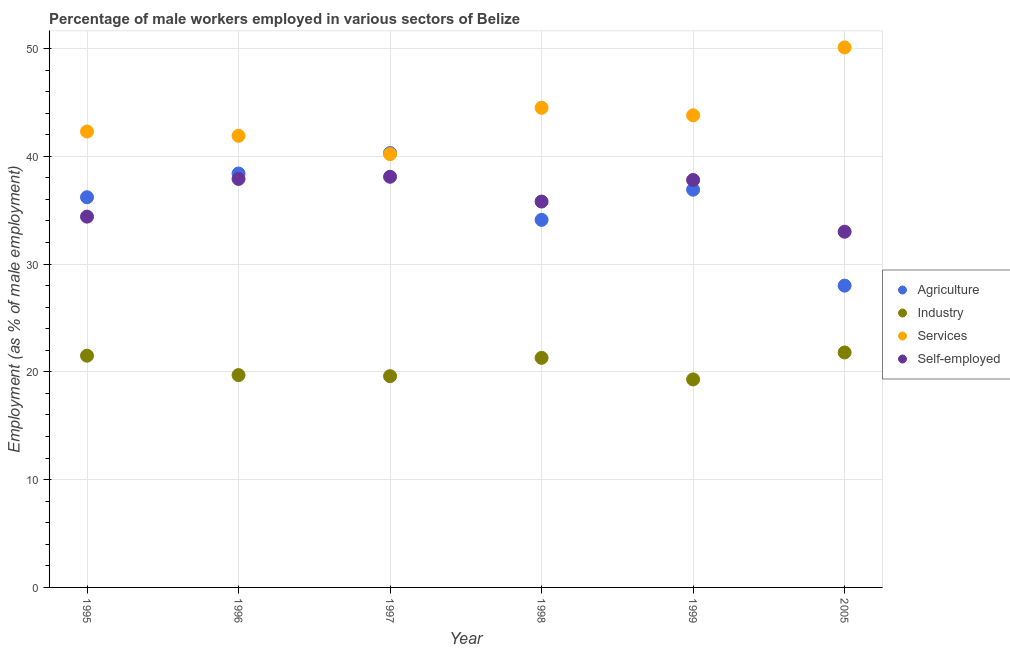Is the number of dotlines equal to the number of legend labels?
Provide a short and direct response. Yes. What is the percentage of self employed male workers in 1995?
Make the answer very short. 34.4. Across all years, what is the maximum percentage of self employed male workers?
Ensure brevity in your answer.  38.1. Across all years, what is the minimum percentage of male workers in agriculture?
Keep it short and to the point. 28. In which year was the percentage of male workers in industry maximum?
Keep it short and to the point. 2005. In which year was the percentage of male workers in agriculture minimum?
Offer a terse response. 2005. What is the total percentage of self employed male workers in the graph?
Your response must be concise. 217. What is the difference between the percentage of male workers in agriculture in 1996 and that in 1997?
Provide a short and direct response. -1.9. What is the difference between the percentage of self employed male workers in 1997 and the percentage of male workers in industry in 1995?
Make the answer very short. 16.6. What is the average percentage of male workers in agriculture per year?
Keep it short and to the point. 35.65. In the year 1995, what is the difference between the percentage of male workers in services and percentage of self employed male workers?
Provide a succinct answer. 7.9. What is the ratio of the percentage of male workers in industry in 1998 to that in 1999?
Give a very brief answer. 1.1. What is the difference between the highest and the second highest percentage of self employed male workers?
Provide a succinct answer. 0.2. What is the difference between the highest and the lowest percentage of male workers in services?
Your answer should be very brief. 9.9. Is the sum of the percentage of male workers in industry in 1996 and 1998 greater than the maximum percentage of self employed male workers across all years?
Make the answer very short. Yes. Is it the case that in every year, the sum of the percentage of male workers in industry and percentage of male workers in services is greater than the sum of percentage of self employed male workers and percentage of male workers in agriculture?
Your answer should be compact. No. How many dotlines are there?
Provide a short and direct response. 4. What is the difference between two consecutive major ticks on the Y-axis?
Your response must be concise. 10. Does the graph contain any zero values?
Ensure brevity in your answer.  No. Does the graph contain grids?
Ensure brevity in your answer.  Yes. Where does the legend appear in the graph?
Keep it short and to the point. Center right. How are the legend labels stacked?
Keep it short and to the point. Vertical. What is the title of the graph?
Offer a terse response. Percentage of male workers employed in various sectors of Belize. What is the label or title of the X-axis?
Ensure brevity in your answer.  Year. What is the label or title of the Y-axis?
Your response must be concise. Employment (as % of male employment). What is the Employment (as % of male employment) of Agriculture in 1995?
Offer a very short reply. 36.2. What is the Employment (as % of male employment) in Services in 1995?
Keep it short and to the point. 42.3. What is the Employment (as % of male employment) in Self-employed in 1995?
Offer a very short reply. 34.4. What is the Employment (as % of male employment) in Agriculture in 1996?
Your response must be concise. 38.4. What is the Employment (as % of male employment) of Industry in 1996?
Make the answer very short. 19.7. What is the Employment (as % of male employment) of Services in 1996?
Your answer should be compact. 41.9. What is the Employment (as % of male employment) in Self-employed in 1996?
Offer a terse response. 37.9. What is the Employment (as % of male employment) of Agriculture in 1997?
Offer a very short reply. 40.3. What is the Employment (as % of male employment) of Industry in 1997?
Ensure brevity in your answer.  19.6. What is the Employment (as % of male employment) of Services in 1997?
Your response must be concise. 40.2. What is the Employment (as % of male employment) in Self-employed in 1997?
Give a very brief answer. 38.1. What is the Employment (as % of male employment) in Agriculture in 1998?
Make the answer very short. 34.1. What is the Employment (as % of male employment) in Industry in 1998?
Your response must be concise. 21.3. What is the Employment (as % of male employment) in Services in 1998?
Ensure brevity in your answer.  44.5. What is the Employment (as % of male employment) of Self-employed in 1998?
Offer a very short reply. 35.8. What is the Employment (as % of male employment) in Agriculture in 1999?
Offer a very short reply. 36.9. What is the Employment (as % of male employment) in Industry in 1999?
Your answer should be very brief. 19.3. What is the Employment (as % of male employment) of Services in 1999?
Make the answer very short. 43.8. What is the Employment (as % of male employment) of Self-employed in 1999?
Provide a succinct answer. 37.8. What is the Employment (as % of male employment) in Agriculture in 2005?
Offer a very short reply. 28. What is the Employment (as % of male employment) in Industry in 2005?
Your response must be concise. 21.8. What is the Employment (as % of male employment) in Services in 2005?
Your response must be concise. 50.1. Across all years, what is the maximum Employment (as % of male employment) in Agriculture?
Keep it short and to the point. 40.3. Across all years, what is the maximum Employment (as % of male employment) of Industry?
Your answer should be compact. 21.8. Across all years, what is the maximum Employment (as % of male employment) in Services?
Your answer should be compact. 50.1. Across all years, what is the maximum Employment (as % of male employment) in Self-employed?
Keep it short and to the point. 38.1. Across all years, what is the minimum Employment (as % of male employment) of Agriculture?
Your answer should be compact. 28. Across all years, what is the minimum Employment (as % of male employment) of Industry?
Give a very brief answer. 19.3. Across all years, what is the minimum Employment (as % of male employment) of Services?
Keep it short and to the point. 40.2. What is the total Employment (as % of male employment) of Agriculture in the graph?
Offer a very short reply. 213.9. What is the total Employment (as % of male employment) of Industry in the graph?
Make the answer very short. 123.2. What is the total Employment (as % of male employment) in Services in the graph?
Your response must be concise. 262.8. What is the total Employment (as % of male employment) of Self-employed in the graph?
Offer a terse response. 217. What is the difference between the Employment (as % of male employment) in Agriculture in 1995 and that in 1996?
Offer a very short reply. -2.2. What is the difference between the Employment (as % of male employment) in Industry in 1995 and that in 1996?
Your answer should be very brief. 1.8. What is the difference between the Employment (as % of male employment) in Services in 1995 and that in 1997?
Provide a succinct answer. 2.1. What is the difference between the Employment (as % of male employment) of Self-employed in 1995 and that in 1997?
Offer a terse response. -3.7. What is the difference between the Employment (as % of male employment) of Agriculture in 1995 and that in 1998?
Your response must be concise. 2.1. What is the difference between the Employment (as % of male employment) of Agriculture in 1995 and that in 1999?
Offer a terse response. -0.7. What is the difference between the Employment (as % of male employment) of Industry in 1995 and that in 1999?
Give a very brief answer. 2.2. What is the difference between the Employment (as % of male employment) of Agriculture in 1995 and that in 2005?
Your response must be concise. 8.2. What is the difference between the Employment (as % of male employment) in Industry in 1995 and that in 2005?
Keep it short and to the point. -0.3. What is the difference between the Employment (as % of male employment) of Agriculture in 1996 and that in 1997?
Make the answer very short. -1.9. What is the difference between the Employment (as % of male employment) of Agriculture in 1996 and that in 1998?
Keep it short and to the point. 4.3. What is the difference between the Employment (as % of male employment) in Industry in 1996 and that in 1998?
Make the answer very short. -1.6. What is the difference between the Employment (as % of male employment) in Services in 1996 and that in 1998?
Provide a short and direct response. -2.6. What is the difference between the Employment (as % of male employment) in Self-employed in 1996 and that in 1998?
Your answer should be compact. 2.1. What is the difference between the Employment (as % of male employment) in Services in 1996 and that in 1999?
Your answer should be very brief. -1.9. What is the difference between the Employment (as % of male employment) of Services in 1996 and that in 2005?
Keep it short and to the point. -8.2. What is the difference between the Employment (as % of male employment) in Self-employed in 1996 and that in 2005?
Your answer should be compact. 4.9. What is the difference between the Employment (as % of male employment) in Agriculture in 1997 and that in 1998?
Your answer should be compact. 6.2. What is the difference between the Employment (as % of male employment) in Industry in 1997 and that in 1998?
Make the answer very short. -1.7. What is the difference between the Employment (as % of male employment) in Services in 1997 and that in 1998?
Make the answer very short. -4.3. What is the difference between the Employment (as % of male employment) in Self-employed in 1997 and that in 1998?
Give a very brief answer. 2.3. What is the difference between the Employment (as % of male employment) of Industry in 1997 and that in 1999?
Offer a terse response. 0.3. What is the difference between the Employment (as % of male employment) of Services in 1997 and that in 1999?
Give a very brief answer. -3.6. What is the difference between the Employment (as % of male employment) of Self-employed in 1997 and that in 2005?
Provide a succinct answer. 5.1. What is the difference between the Employment (as % of male employment) in Agriculture in 1998 and that in 1999?
Offer a very short reply. -2.8. What is the difference between the Employment (as % of male employment) of Industry in 1998 and that in 1999?
Offer a very short reply. 2. What is the difference between the Employment (as % of male employment) of Services in 1998 and that in 1999?
Provide a short and direct response. 0.7. What is the difference between the Employment (as % of male employment) of Agriculture in 1999 and that in 2005?
Provide a short and direct response. 8.9. What is the difference between the Employment (as % of male employment) of Industry in 1999 and that in 2005?
Provide a short and direct response. -2.5. What is the difference between the Employment (as % of male employment) of Services in 1999 and that in 2005?
Give a very brief answer. -6.3. What is the difference between the Employment (as % of male employment) in Agriculture in 1995 and the Employment (as % of male employment) in Self-employed in 1996?
Your answer should be compact. -1.7. What is the difference between the Employment (as % of male employment) in Industry in 1995 and the Employment (as % of male employment) in Services in 1996?
Give a very brief answer. -20.4. What is the difference between the Employment (as % of male employment) in Industry in 1995 and the Employment (as % of male employment) in Self-employed in 1996?
Offer a terse response. -16.4. What is the difference between the Employment (as % of male employment) of Agriculture in 1995 and the Employment (as % of male employment) of Services in 1997?
Your answer should be compact. -4. What is the difference between the Employment (as % of male employment) in Industry in 1995 and the Employment (as % of male employment) in Services in 1997?
Ensure brevity in your answer.  -18.7. What is the difference between the Employment (as % of male employment) of Industry in 1995 and the Employment (as % of male employment) of Self-employed in 1997?
Offer a very short reply. -16.6. What is the difference between the Employment (as % of male employment) in Industry in 1995 and the Employment (as % of male employment) in Services in 1998?
Your answer should be compact. -23. What is the difference between the Employment (as % of male employment) of Industry in 1995 and the Employment (as % of male employment) of Self-employed in 1998?
Your response must be concise. -14.3. What is the difference between the Employment (as % of male employment) of Services in 1995 and the Employment (as % of male employment) of Self-employed in 1998?
Make the answer very short. 6.5. What is the difference between the Employment (as % of male employment) of Agriculture in 1995 and the Employment (as % of male employment) of Industry in 1999?
Ensure brevity in your answer.  16.9. What is the difference between the Employment (as % of male employment) of Industry in 1995 and the Employment (as % of male employment) of Services in 1999?
Offer a terse response. -22.3. What is the difference between the Employment (as % of male employment) of Industry in 1995 and the Employment (as % of male employment) of Self-employed in 1999?
Provide a short and direct response. -16.3. What is the difference between the Employment (as % of male employment) in Agriculture in 1995 and the Employment (as % of male employment) in Industry in 2005?
Your response must be concise. 14.4. What is the difference between the Employment (as % of male employment) in Industry in 1995 and the Employment (as % of male employment) in Services in 2005?
Make the answer very short. -28.6. What is the difference between the Employment (as % of male employment) in Services in 1995 and the Employment (as % of male employment) in Self-employed in 2005?
Offer a very short reply. 9.3. What is the difference between the Employment (as % of male employment) in Agriculture in 1996 and the Employment (as % of male employment) in Services in 1997?
Your answer should be very brief. -1.8. What is the difference between the Employment (as % of male employment) in Industry in 1996 and the Employment (as % of male employment) in Services in 1997?
Your answer should be compact. -20.5. What is the difference between the Employment (as % of male employment) in Industry in 1996 and the Employment (as % of male employment) in Self-employed in 1997?
Your answer should be very brief. -18.4. What is the difference between the Employment (as % of male employment) in Services in 1996 and the Employment (as % of male employment) in Self-employed in 1997?
Offer a very short reply. 3.8. What is the difference between the Employment (as % of male employment) of Industry in 1996 and the Employment (as % of male employment) of Services in 1998?
Keep it short and to the point. -24.8. What is the difference between the Employment (as % of male employment) in Industry in 1996 and the Employment (as % of male employment) in Self-employed in 1998?
Make the answer very short. -16.1. What is the difference between the Employment (as % of male employment) of Agriculture in 1996 and the Employment (as % of male employment) of Industry in 1999?
Provide a short and direct response. 19.1. What is the difference between the Employment (as % of male employment) of Agriculture in 1996 and the Employment (as % of male employment) of Self-employed in 1999?
Your answer should be very brief. 0.6. What is the difference between the Employment (as % of male employment) in Industry in 1996 and the Employment (as % of male employment) in Services in 1999?
Offer a very short reply. -24.1. What is the difference between the Employment (as % of male employment) of Industry in 1996 and the Employment (as % of male employment) of Self-employed in 1999?
Make the answer very short. -18.1. What is the difference between the Employment (as % of male employment) in Agriculture in 1996 and the Employment (as % of male employment) in Industry in 2005?
Your answer should be very brief. 16.6. What is the difference between the Employment (as % of male employment) of Industry in 1996 and the Employment (as % of male employment) of Services in 2005?
Your answer should be compact. -30.4. What is the difference between the Employment (as % of male employment) in Services in 1996 and the Employment (as % of male employment) in Self-employed in 2005?
Provide a short and direct response. 8.9. What is the difference between the Employment (as % of male employment) of Agriculture in 1997 and the Employment (as % of male employment) of Industry in 1998?
Your answer should be very brief. 19. What is the difference between the Employment (as % of male employment) in Agriculture in 1997 and the Employment (as % of male employment) in Services in 1998?
Your answer should be compact. -4.2. What is the difference between the Employment (as % of male employment) of Agriculture in 1997 and the Employment (as % of male employment) of Self-employed in 1998?
Your answer should be very brief. 4.5. What is the difference between the Employment (as % of male employment) of Industry in 1997 and the Employment (as % of male employment) of Services in 1998?
Your answer should be compact. -24.9. What is the difference between the Employment (as % of male employment) of Industry in 1997 and the Employment (as % of male employment) of Self-employed in 1998?
Ensure brevity in your answer.  -16.2. What is the difference between the Employment (as % of male employment) in Agriculture in 1997 and the Employment (as % of male employment) in Services in 1999?
Provide a short and direct response. -3.5. What is the difference between the Employment (as % of male employment) in Industry in 1997 and the Employment (as % of male employment) in Services in 1999?
Offer a very short reply. -24.2. What is the difference between the Employment (as % of male employment) in Industry in 1997 and the Employment (as % of male employment) in Self-employed in 1999?
Provide a succinct answer. -18.2. What is the difference between the Employment (as % of male employment) in Agriculture in 1997 and the Employment (as % of male employment) in Industry in 2005?
Your response must be concise. 18.5. What is the difference between the Employment (as % of male employment) in Agriculture in 1997 and the Employment (as % of male employment) in Self-employed in 2005?
Your answer should be very brief. 7.3. What is the difference between the Employment (as % of male employment) in Industry in 1997 and the Employment (as % of male employment) in Services in 2005?
Ensure brevity in your answer.  -30.5. What is the difference between the Employment (as % of male employment) in Agriculture in 1998 and the Employment (as % of male employment) in Services in 1999?
Your answer should be very brief. -9.7. What is the difference between the Employment (as % of male employment) of Agriculture in 1998 and the Employment (as % of male employment) of Self-employed in 1999?
Keep it short and to the point. -3.7. What is the difference between the Employment (as % of male employment) of Industry in 1998 and the Employment (as % of male employment) of Services in 1999?
Keep it short and to the point. -22.5. What is the difference between the Employment (as % of male employment) in Industry in 1998 and the Employment (as % of male employment) in Self-employed in 1999?
Offer a very short reply. -16.5. What is the difference between the Employment (as % of male employment) of Agriculture in 1998 and the Employment (as % of male employment) of Industry in 2005?
Offer a very short reply. 12.3. What is the difference between the Employment (as % of male employment) in Industry in 1998 and the Employment (as % of male employment) in Services in 2005?
Your response must be concise. -28.8. What is the difference between the Employment (as % of male employment) of Industry in 1998 and the Employment (as % of male employment) of Self-employed in 2005?
Your answer should be compact. -11.7. What is the difference between the Employment (as % of male employment) in Agriculture in 1999 and the Employment (as % of male employment) in Industry in 2005?
Keep it short and to the point. 15.1. What is the difference between the Employment (as % of male employment) in Agriculture in 1999 and the Employment (as % of male employment) in Self-employed in 2005?
Ensure brevity in your answer.  3.9. What is the difference between the Employment (as % of male employment) of Industry in 1999 and the Employment (as % of male employment) of Services in 2005?
Give a very brief answer. -30.8. What is the difference between the Employment (as % of male employment) of Industry in 1999 and the Employment (as % of male employment) of Self-employed in 2005?
Your answer should be very brief. -13.7. What is the average Employment (as % of male employment) in Agriculture per year?
Make the answer very short. 35.65. What is the average Employment (as % of male employment) of Industry per year?
Your answer should be very brief. 20.53. What is the average Employment (as % of male employment) of Services per year?
Provide a succinct answer. 43.8. What is the average Employment (as % of male employment) in Self-employed per year?
Ensure brevity in your answer.  36.17. In the year 1995, what is the difference between the Employment (as % of male employment) in Agriculture and Employment (as % of male employment) in Industry?
Your response must be concise. 14.7. In the year 1995, what is the difference between the Employment (as % of male employment) of Agriculture and Employment (as % of male employment) of Services?
Your answer should be very brief. -6.1. In the year 1995, what is the difference between the Employment (as % of male employment) in Agriculture and Employment (as % of male employment) in Self-employed?
Give a very brief answer. 1.8. In the year 1995, what is the difference between the Employment (as % of male employment) in Industry and Employment (as % of male employment) in Services?
Your answer should be very brief. -20.8. In the year 1995, what is the difference between the Employment (as % of male employment) of Services and Employment (as % of male employment) of Self-employed?
Provide a short and direct response. 7.9. In the year 1996, what is the difference between the Employment (as % of male employment) in Agriculture and Employment (as % of male employment) in Industry?
Offer a very short reply. 18.7. In the year 1996, what is the difference between the Employment (as % of male employment) of Agriculture and Employment (as % of male employment) of Services?
Give a very brief answer. -3.5. In the year 1996, what is the difference between the Employment (as % of male employment) in Industry and Employment (as % of male employment) in Services?
Offer a terse response. -22.2. In the year 1996, what is the difference between the Employment (as % of male employment) of Industry and Employment (as % of male employment) of Self-employed?
Ensure brevity in your answer.  -18.2. In the year 1996, what is the difference between the Employment (as % of male employment) in Services and Employment (as % of male employment) in Self-employed?
Give a very brief answer. 4. In the year 1997, what is the difference between the Employment (as % of male employment) of Agriculture and Employment (as % of male employment) of Industry?
Give a very brief answer. 20.7. In the year 1997, what is the difference between the Employment (as % of male employment) of Industry and Employment (as % of male employment) of Services?
Provide a short and direct response. -20.6. In the year 1997, what is the difference between the Employment (as % of male employment) in Industry and Employment (as % of male employment) in Self-employed?
Your response must be concise. -18.5. In the year 1998, what is the difference between the Employment (as % of male employment) in Agriculture and Employment (as % of male employment) in Services?
Provide a short and direct response. -10.4. In the year 1998, what is the difference between the Employment (as % of male employment) of Industry and Employment (as % of male employment) of Services?
Provide a short and direct response. -23.2. In the year 1998, what is the difference between the Employment (as % of male employment) in Industry and Employment (as % of male employment) in Self-employed?
Give a very brief answer. -14.5. In the year 1999, what is the difference between the Employment (as % of male employment) of Industry and Employment (as % of male employment) of Services?
Make the answer very short. -24.5. In the year 1999, what is the difference between the Employment (as % of male employment) in Industry and Employment (as % of male employment) in Self-employed?
Make the answer very short. -18.5. In the year 2005, what is the difference between the Employment (as % of male employment) in Agriculture and Employment (as % of male employment) in Services?
Make the answer very short. -22.1. In the year 2005, what is the difference between the Employment (as % of male employment) of Industry and Employment (as % of male employment) of Services?
Ensure brevity in your answer.  -28.3. What is the ratio of the Employment (as % of male employment) in Agriculture in 1995 to that in 1996?
Keep it short and to the point. 0.94. What is the ratio of the Employment (as % of male employment) in Industry in 1995 to that in 1996?
Offer a terse response. 1.09. What is the ratio of the Employment (as % of male employment) of Services in 1995 to that in 1996?
Provide a succinct answer. 1.01. What is the ratio of the Employment (as % of male employment) of Self-employed in 1995 to that in 1996?
Your answer should be very brief. 0.91. What is the ratio of the Employment (as % of male employment) in Agriculture in 1995 to that in 1997?
Offer a terse response. 0.9. What is the ratio of the Employment (as % of male employment) of Industry in 1995 to that in 1997?
Provide a short and direct response. 1.1. What is the ratio of the Employment (as % of male employment) of Services in 1995 to that in 1997?
Provide a succinct answer. 1.05. What is the ratio of the Employment (as % of male employment) of Self-employed in 1995 to that in 1997?
Your response must be concise. 0.9. What is the ratio of the Employment (as % of male employment) of Agriculture in 1995 to that in 1998?
Provide a short and direct response. 1.06. What is the ratio of the Employment (as % of male employment) in Industry in 1995 to that in 1998?
Provide a short and direct response. 1.01. What is the ratio of the Employment (as % of male employment) of Services in 1995 to that in 1998?
Give a very brief answer. 0.95. What is the ratio of the Employment (as % of male employment) of Self-employed in 1995 to that in 1998?
Your response must be concise. 0.96. What is the ratio of the Employment (as % of male employment) in Industry in 1995 to that in 1999?
Your answer should be very brief. 1.11. What is the ratio of the Employment (as % of male employment) of Services in 1995 to that in 1999?
Provide a succinct answer. 0.97. What is the ratio of the Employment (as % of male employment) in Self-employed in 1995 to that in 1999?
Offer a very short reply. 0.91. What is the ratio of the Employment (as % of male employment) in Agriculture in 1995 to that in 2005?
Your answer should be compact. 1.29. What is the ratio of the Employment (as % of male employment) in Industry in 1995 to that in 2005?
Your response must be concise. 0.99. What is the ratio of the Employment (as % of male employment) in Services in 1995 to that in 2005?
Your answer should be compact. 0.84. What is the ratio of the Employment (as % of male employment) of Self-employed in 1995 to that in 2005?
Give a very brief answer. 1.04. What is the ratio of the Employment (as % of male employment) in Agriculture in 1996 to that in 1997?
Give a very brief answer. 0.95. What is the ratio of the Employment (as % of male employment) of Industry in 1996 to that in 1997?
Provide a succinct answer. 1.01. What is the ratio of the Employment (as % of male employment) in Services in 1996 to that in 1997?
Provide a succinct answer. 1.04. What is the ratio of the Employment (as % of male employment) of Self-employed in 1996 to that in 1997?
Keep it short and to the point. 0.99. What is the ratio of the Employment (as % of male employment) in Agriculture in 1996 to that in 1998?
Offer a very short reply. 1.13. What is the ratio of the Employment (as % of male employment) in Industry in 1996 to that in 1998?
Make the answer very short. 0.92. What is the ratio of the Employment (as % of male employment) in Services in 1996 to that in 1998?
Give a very brief answer. 0.94. What is the ratio of the Employment (as % of male employment) of Self-employed in 1996 to that in 1998?
Keep it short and to the point. 1.06. What is the ratio of the Employment (as % of male employment) in Agriculture in 1996 to that in 1999?
Provide a short and direct response. 1.04. What is the ratio of the Employment (as % of male employment) in Industry in 1996 to that in 1999?
Give a very brief answer. 1.02. What is the ratio of the Employment (as % of male employment) in Services in 1996 to that in 1999?
Your answer should be very brief. 0.96. What is the ratio of the Employment (as % of male employment) of Agriculture in 1996 to that in 2005?
Provide a short and direct response. 1.37. What is the ratio of the Employment (as % of male employment) of Industry in 1996 to that in 2005?
Your response must be concise. 0.9. What is the ratio of the Employment (as % of male employment) of Services in 1996 to that in 2005?
Provide a succinct answer. 0.84. What is the ratio of the Employment (as % of male employment) of Self-employed in 1996 to that in 2005?
Ensure brevity in your answer.  1.15. What is the ratio of the Employment (as % of male employment) in Agriculture in 1997 to that in 1998?
Make the answer very short. 1.18. What is the ratio of the Employment (as % of male employment) in Industry in 1997 to that in 1998?
Your answer should be compact. 0.92. What is the ratio of the Employment (as % of male employment) of Services in 1997 to that in 1998?
Your answer should be very brief. 0.9. What is the ratio of the Employment (as % of male employment) in Self-employed in 1997 to that in 1998?
Offer a terse response. 1.06. What is the ratio of the Employment (as % of male employment) in Agriculture in 1997 to that in 1999?
Your answer should be very brief. 1.09. What is the ratio of the Employment (as % of male employment) in Industry in 1997 to that in 1999?
Ensure brevity in your answer.  1.02. What is the ratio of the Employment (as % of male employment) in Services in 1997 to that in 1999?
Give a very brief answer. 0.92. What is the ratio of the Employment (as % of male employment) of Self-employed in 1997 to that in 1999?
Your answer should be very brief. 1.01. What is the ratio of the Employment (as % of male employment) of Agriculture in 1997 to that in 2005?
Offer a very short reply. 1.44. What is the ratio of the Employment (as % of male employment) in Industry in 1997 to that in 2005?
Give a very brief answer. 0.9. What is the ratio of the Employment (as % of male employment) in Services in 1997 to that in 2005?
Provide a short and direct response. 0.8. What is the ratio of the Employment (as % of male employment) in Self-employed in 1997 to that in 2005?
Your answer should be very brief. 1.15. What is the ratio of the Employment (as % of male employment) of Agriculture in 1998 to that in 1999?
Provide a short and direct response. 0.92. What is the ratio of the Employment (as % of male employment) in Industry in 1998 to that in 1999?
Offer a very short reply. 1.1. What is the ratio of the Employment (as % of male employment) of Services in 1998 to that in 1999?
Provide a succinct answer. 1.02. What is the ratio of the Employment (as % of male employment) in Self-employed in 1998 to that in 1999?
Give a very brief answer. 0.95. What is the ratio of the Employment (as % of male employment) in Agriculture in 1998 to that in 2005?
Your answer should be very brief. 1.22. What is the ratio of the Employment (as % of male employment) in Industry in 1998 to that in 2005?
Provide a short and direct response. 0.98. What is the ratio of the Employment (as % of male employment) in Services in 1998 to that in 2005?
Make the answer very short. 0.89. What is the ratio of the Employment (as % of male employment) in Self-employed in 1998 to that in 2005?
Your answer should be very brief. 1.08. What is the ratio of the Employment (as % of male employment) in Agriculture in 1999 to that in 2005?
Provide a short and direct response. 1.32. What is the ratio of the Employment (as % of male employment) of Industry in 1999 to that in 2005?
Your response must be concise. 0.89. What is the ratio of the Employment (as % of male employment) in Services in 1999 to that in 2005?
Provide a succinct answer. 0.87. What is the ratio of the Employment (as % of male employment) in Self-employed in 1999 to that in 2005?
Provide a succinct answer. 1.15. What is the difference between the highest and the second highest Employment (as % of male employment) in Agriculture?
Offer a very short reply. 1.9. What is the difference between the highest and the lowest Employment (as % of male employment) in Agriculture?
Your answer should be very brief. 12.3. What is the difference between the highest and the lowest Employment (as % of male employment) of Industry?
Make the answer very short. 2.5. What is the difference between the highest and the lowest Employment (as % of male employment) of Self-employed?
Keep it short and to the point. 5.1. 